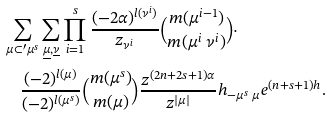<formula> <loc_0><loc_0><loc_500><loc_500>& \sum _ { \mu \subset ^ { \prime } \mu ^ { s } } \sum _ { \underline { \mu } , \underline { \nu } } \prod _ { i = 1 } ^ { s } \frac { ( - 2 { \alpha } ) ^ { l ( \nu ^ { i } ) } } { z _ { \nu ^ { i } } } \binom { m ( \mu ^ { i - 1 } ) } { m ( \mu ^ { i } \ \nu ^ { i } ) } \cdot \\ & \quad \frac { ( - 2 ) ^ { l ( \mu ) } } { ( - 2 ) ^ { l ( \mu ^ { s } ) } } \binom { m ( \mu ^ { s } ) } { m ( \mu ) } \frac { z ^ { ( 2 n + 2 s + 1 ) { \alpha } } } { z ^ { | \mu | } } h _ { - \mu ^ { s } \ \mu } e ^ { ( n + s + 1 ) h } .</formula> 